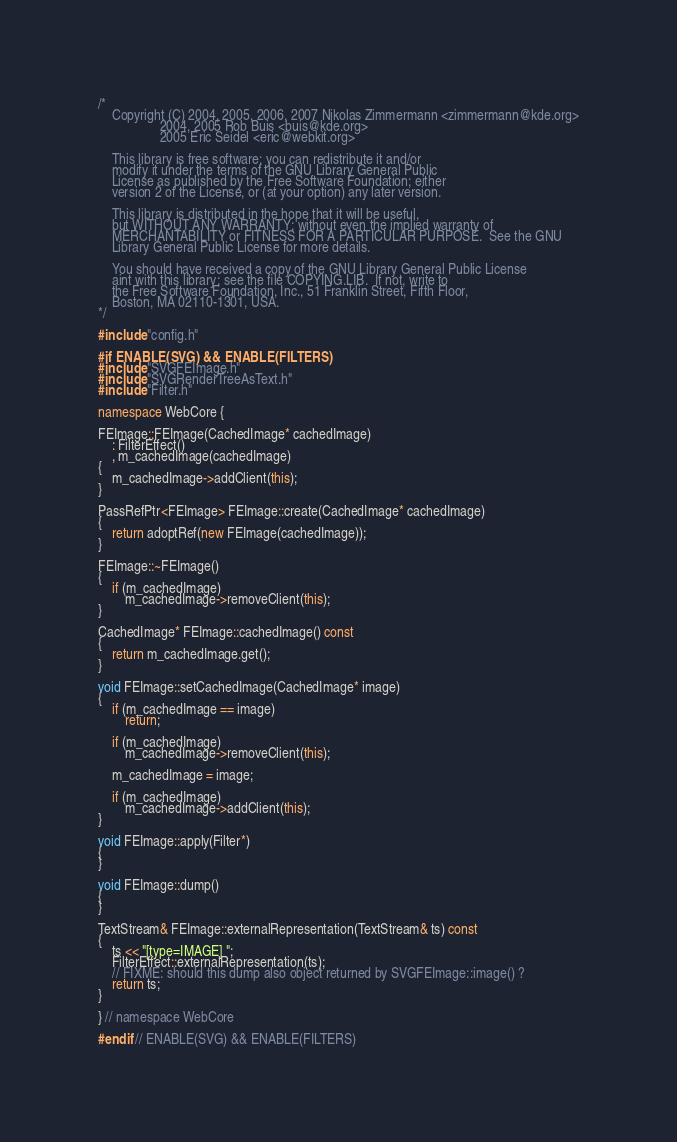<code> <loc_0><loc_0><loc_500><loc_500><_C++_>/*
    Copyright (C) 2004, 2005, 2006, 2007 Nikolas Zimmermann <zimmermann@kde.org>
                  2004, 2005 Rob Buis <buis@kde.org>
                  2005 Eric Seidel <eric@webkit.org>

    This library is free software; you can redistribute it and/or
    modify it under the terms of the GNU Library General Public
    License as published by the Free Software Foundation; either
    version 2 of the License, or (at your option) any later version.

    This library is distributed in the hope that it will be useful,
    but WITHOUT ANY WARRANTY; without even the implied warranty of
    MERCHANTABILITY or FITNESS FOR A PARTICULAR PURPOSE.  See the GNU
    Library General Public License for more details.

    You should have received a copy of the GNU Library General Public License
    aint with this library; see the file COPYING.LIB.  If not, write to
    the Free Software Foundation, Inc., 51 Franklin Street, Fifth Floor,
    Boston, MA 02110-1301, USA.
*/

#include "config.h"

#if ENABLE(SVG) && ENABLE(FILTERS)
#include "SVGFEImage.h"
#include "SVGRenderTreeAsText.h"
#include "Filter.h"

namespace WebCore {

FEImage::FEImage(CachedImage* cachedImage)
    : FilterEffect()
    , m_cachedImage(cachedImage)
{
    m_cachedImage->addClient(this);
}

PassRefPtr<FEImage> FEImage::create(CachedImage* cachedImage)
{
    return adoptRef(new FEImage(cachedImage));
}

FEImage::~FEImage()
{
    if (m_cachedImage)
        m_cachedImage->removeClient(this);
}

CachedImage* FEImage::cachedImage() const
{
    return m_cachedImage.get();
}

void FEImage::setCachedImage(CachedImage* image)
{
    if (m_cachedImage == image)
        return;
    
    if (m_cachedImage)
        m_cachedImage->removeClient(this);

    m_cachedImage = image;

    if (m_cachedImage)
        m_cachedImage->addClient(this);
}

void FEImage::apply(Filter*)
{
}

void FEImage::dump()
{
}

TextStream& FEImage::externalRepresentation(TextStream& ts) const
{
    ts << "[type=IMAGE] ";
    FilterEffect::externalRepresentation(ts);
    // FIXME: should this dump also object returned by SVGFEImage::image() ?
    return ts;
}

} // namespace WebCore

#endif // ENABLE(SVG) && ENABLE(FILTERS)
</code> 